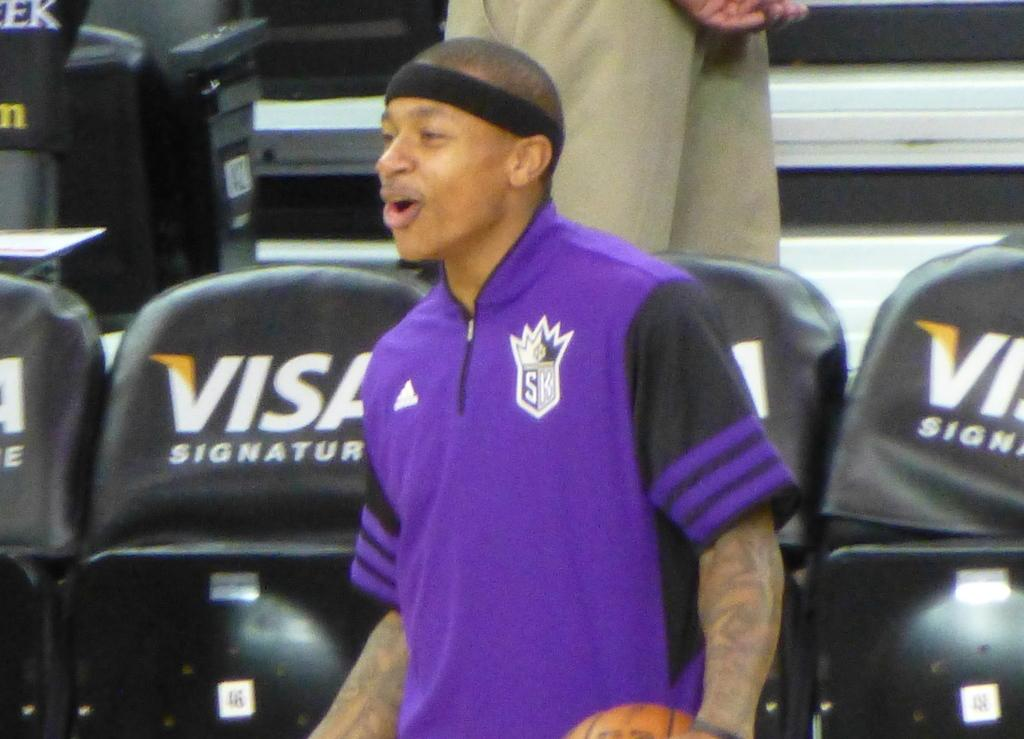Provide a one-sentence caption for the provided image. A basketball player stands next to chairs embedded with the text VISA SIGNATURE. 